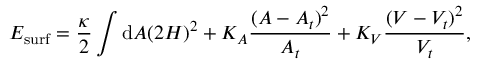Convert formula to latex. <formula><loc_0><loc_0><loc_500><loc_500>E _ { s u r f } = \frac { \kappa } { 2 } \int d A ( 2 H ) ^ { 2 } + K _ { A } \frac { ( A - A _ { t } ) ^ { 2 } } { A _ { t } } + K _ { V } \frac { ( V - V _ { t } ) ^ { 2 } } { V _ { t } } ,</formula> 